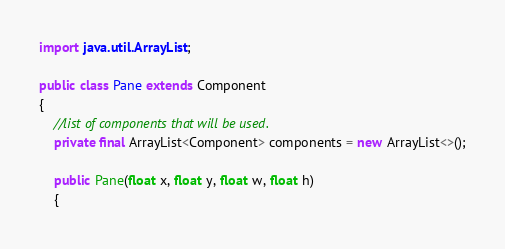<code> <loc_0><loc_0><loc_500><loc_500><_Java_>
import java.util.ArrayList;

public class Pane extends Component
{
	//list of components that will be used.
	private final ArrayList<Component> components = new ArrayList<>();

	public Pane(float x, float y, float w, float h)
	{</code> 